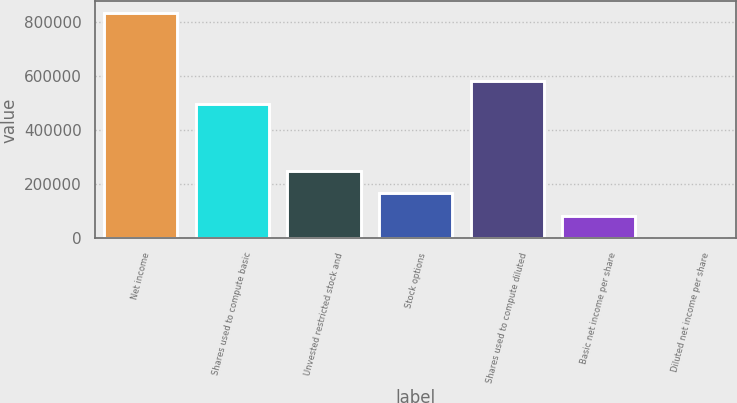Convert chart. <chart><loc_0><loc_0><loc_500><loc_500><bar_chart><fcel>Net income<fcel>Shares used to compute basic<fcel>Unvested restricted stock and<fcel>Stock options<fcel>Shares used to compute diluted<fcel>Basic net income per share<fcel>Diluted net income per share<nl><fcel>832847<fcel>497469<fcel>249855<fcel>166571<fcel>580754<fcel>83286.2<fcel>1.65<nl></chart> 